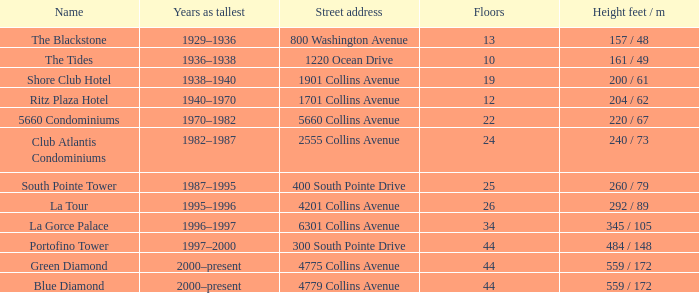How many storeys are there in the blue diamond? 44.0. 